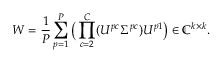<formula> <loc_0><loc_0><loc_500><loc_500>W = \frac { 1 } { P } \sum _ { p = 1 } ^ { P } \left ( \prod _ { c = 2 } ^ { C } ( U ^ { p c } \Sigma ^ { p c } ) U ^ { p 1 } \right ) \in \mathbb { C } ^ { k \times k } .</formula> 